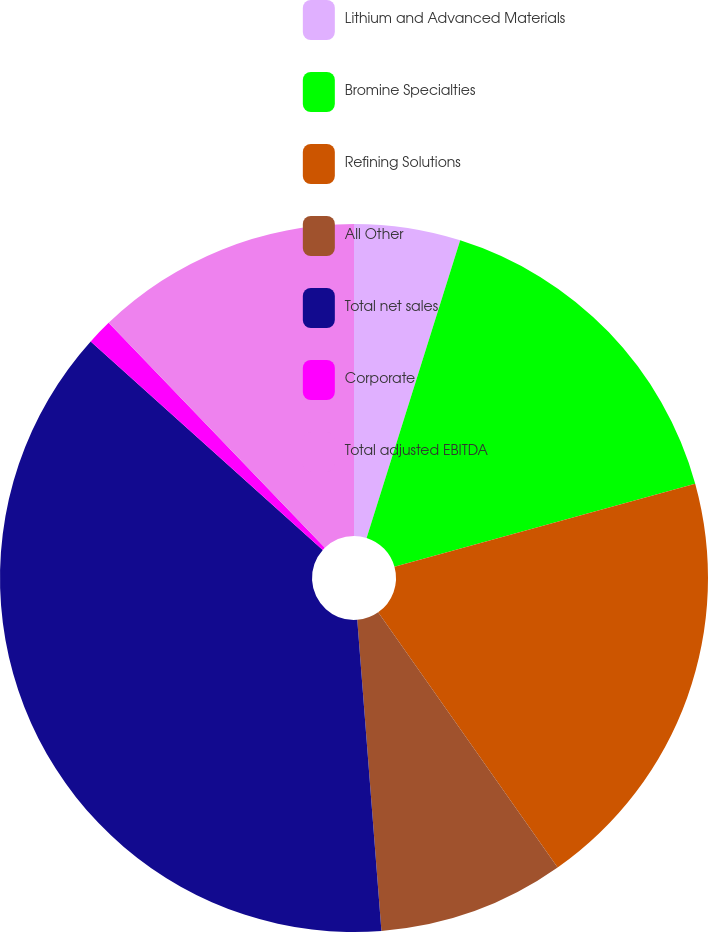Convert chart. <chart><loc_0><loc_0><loc_500><loc_500><pie_chart><fcel>Lithium and Advanced Materials<fcel>Bromine Specialties<fcel>Refining Solutions<fcel>All Other<fcel>Total net sales<fcel>Corporate<fcel>Total adjusted EBITDA<nl><fcel>4.85%<fcel>15.86%<fcel>19.54%<fcel>8.52%<fcel>37.89%<fcel>1.16%<fcel>12.19%<nl></chart> 